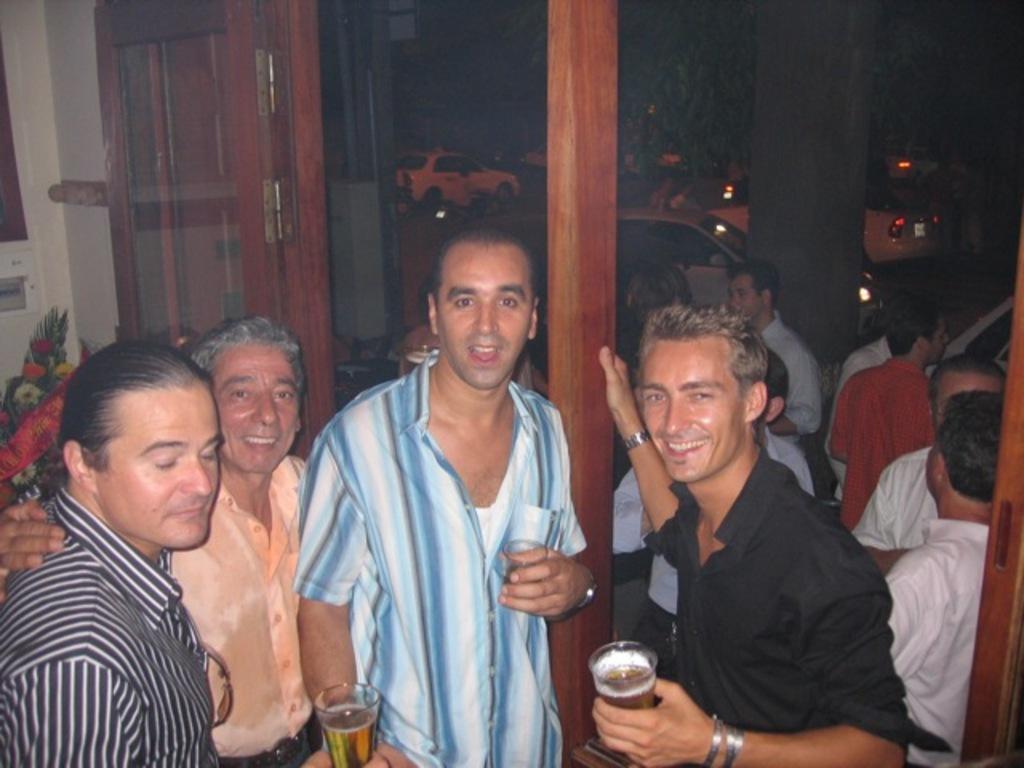Can you describe this image briefly? In this image we can see many persons standing. On the left side of the image we can see door and bouquet. In the background we can see persons, cars, pillar and tree. 